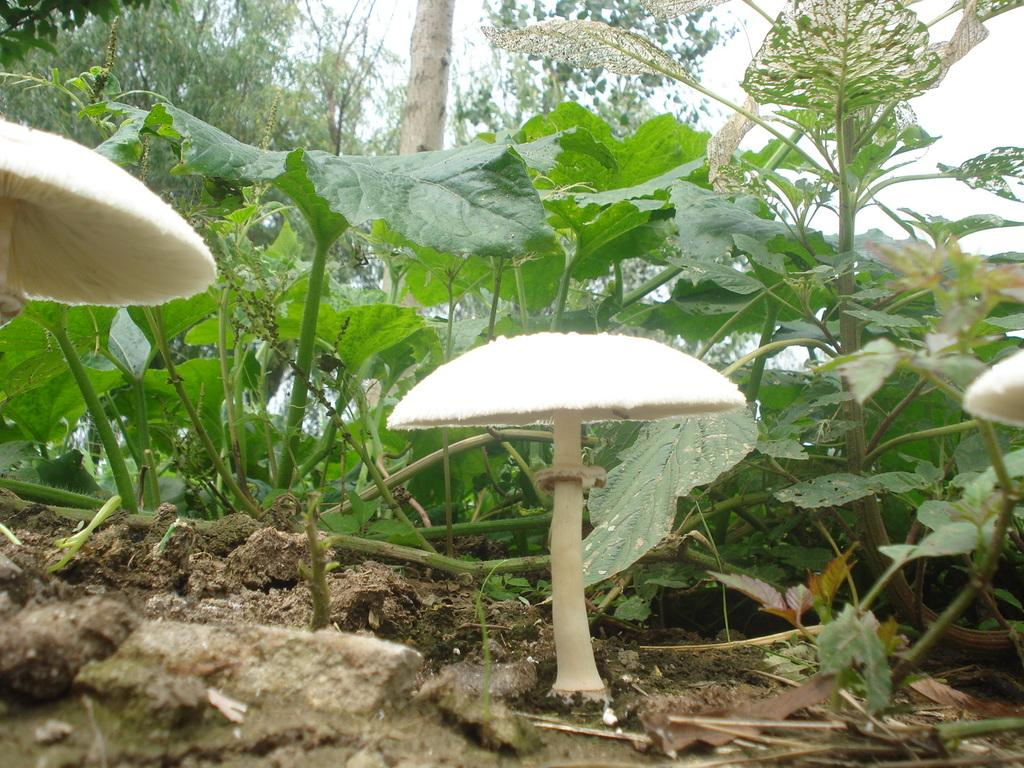What type of vegetation can be seen in the image? There are mushrooms, plants, and trees visible in the image. What type of terrain is present in the image? There is sand visible in the image. What is visible in the background of the image? The sky is visible in the image. How many minutes does it take for the bag to grow in the image? There is no bag present in the image, so it is not possible to determine how long it would take for it to grow. 